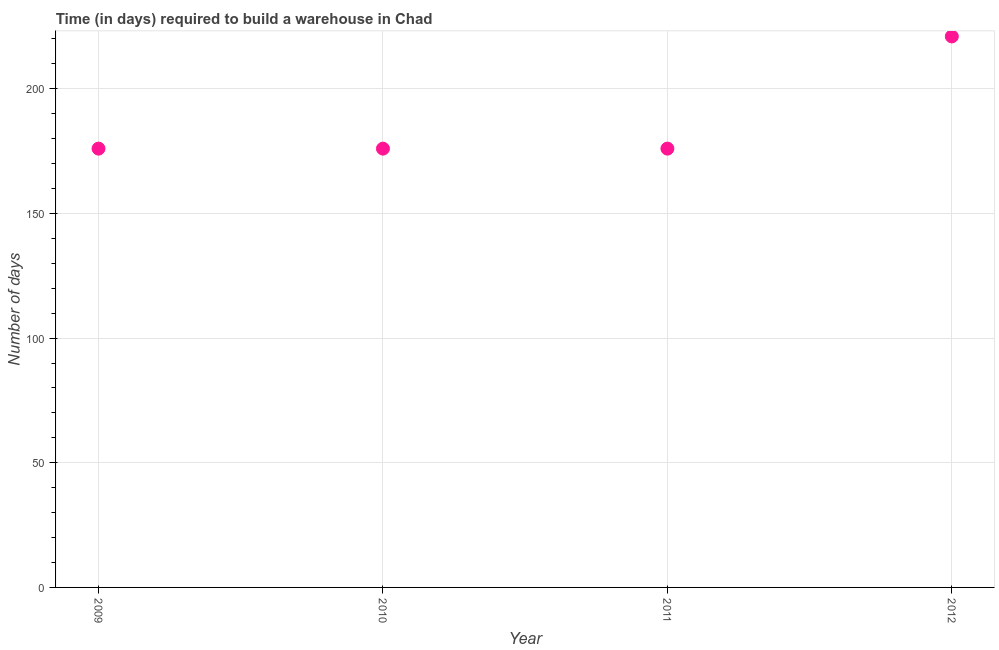What is the time required to build a warehouse in 2011?
Keep it short and to the point. 176. Across all years, what is the maximum time required to build a warehouse?
Make the answer very short. 221. Across all years, what is the minimum time required to build a warehouse?
Your answer should be very brief. 176. In which year was the time required to build a warehouse minimum?
Offer a terse response. 2009. What is the sum of the time required to build a warehouse?
Keep it short and to the point. 749. What is the difference between the time required to build a warehouse in 2009 and 2012?
Make the answer very short. -45. What is the average time required to build a warehouse per year?
Offer a terse response. 187.25. What is the median time required to build a warehouse?
Give a very brief answer. 176. Do a majority of the years between 2011 and 2010 (inclusive) have time required to build a warehouse greater than 170 days?
Your response must be concise. No. What is the ratio of the time required to build a warehouse in 2009 to that in 2012?
Make the answer very short. 0.8. What is the difference between the highest and the second highest time required to build a warehouse?
Offer a terse response. 45. What is the difference between the highest and the lowest time required to build a warehouse?
Offer a very short reply. 45. Does the time required to build a warehouse monotonically increase over the years?
Offer a very short reply. No. How many dotlines are there?
Make the answer very short. 1. How many years are there in the graph?
Provide a succinct answer. 4. Does the graph contain grids?
Provide a succinct answer. Yes. What is the title of the graph?
Ensure brevity in your answer.  Time (in days) required to build a warehouse in Chad. What is the label or title of the Y-axis?
Offer a very short reply. Number of days. What is the Number of days in 2009?
Make the answer very short. 176. What is the Number of days in 2010?
Provide a succinct answer. 176. What is the Number of days in 2011?
Your response must be concise. 176. What is the Number of days in 2012?
Offer a terse response. 221. What is the difference between the Number of days in 2009 and 2010?
Offer a very short reply. 0. What is the difference between the Number of days in 2009 and 2011?
Your answer should be compact. 0. What is the difference between the Number of days in 2009 and 2012?
Provide a short and direct response. -45. What is the difference between the Number of days in 2010 and 2012?
Offer a terse response. -45. What is the difference between the Number of days in 2011 and 2012?
Keep it short and to the point. -45. What is the ratio of the Number of days in 2009 to that in 2011?
Give a very brief answer. 1. What is the ratio of the Number of days in 2009 to that in 2012?
Provide a succinct answer. 0.8. What is the ratio of the Number of days in 2010 to that in 2011?
Provide a short and direct response. 1. What is the ratio of the Number of days in 2010 to that in 2012?
Provide a short and direct response. 0.8. What is the ratio of the Number of days in 2011 to that in 2012?
Provide a succinct answer. 0.8. 